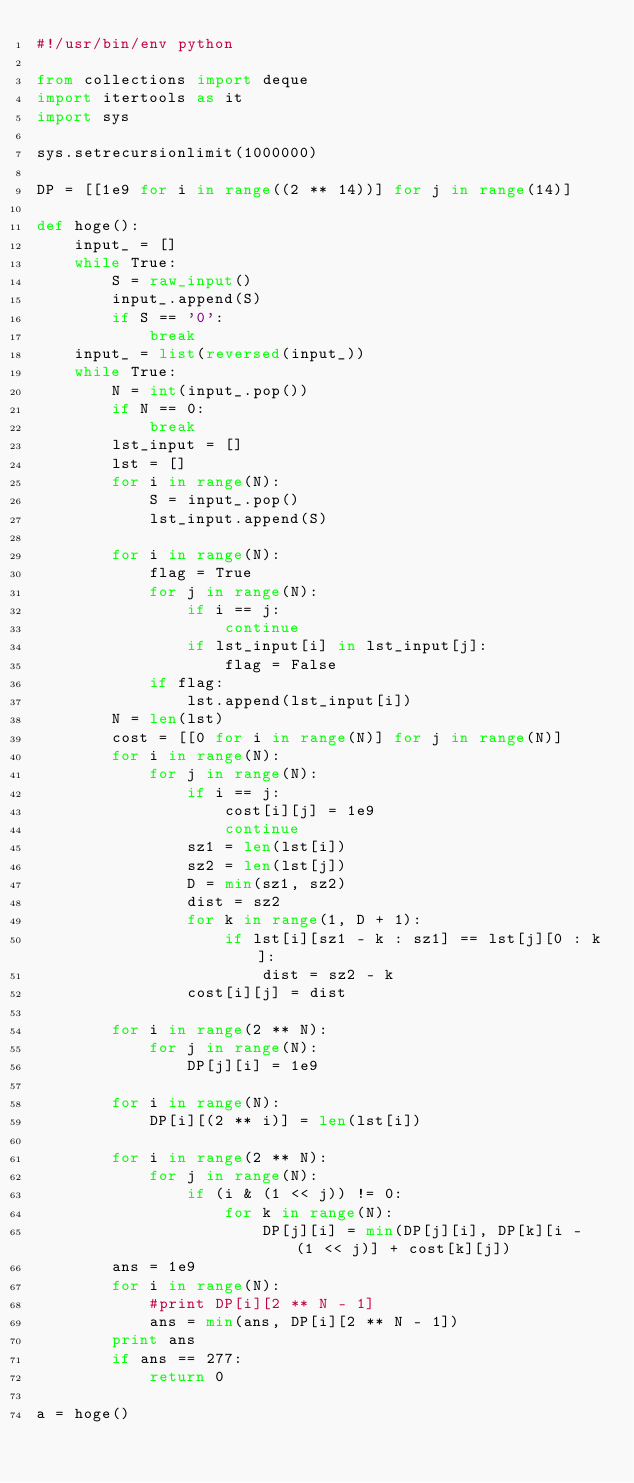<code> <loc_0><loc_0><loc_500><loc_500><_Python_>#!/usr/bin/env python

from collections import deque
import itertools as it
import sys

sys.setrecursionlimit(1000000)

DP = [[1e9 for i in range((2 ** 14))] for j in range(14)]

def hoge():
    input_ = []
    while True:
        S = raw_input()
        input_.append(S)
        if S == '0':
            break
    input_ = list(reversed(input_))
    while True:
        N = int(input_.pop())
        if N == 0:
            break
        lst_input = []
        lst = []
        for i in range(N):
            S = input_.pop()
            lst_input.append(S)
        
        for i in range(N):
            flag = True
            for j in range(N):
                if i == j:
                    continue
                if lst_input[i] in lst_input[j]:
                    flag = False
            if flag:
                lst.append(lst_input[i])
        N = len(lst)
        cost = [[0 for i in range(N)] for j in range(N)]
        for i in range(N):
            for j in range(N):
                if i == j:
                    cost[i][j] = 1e9
                    continue
                sz1 = len(lst[i])
                sz2 = len(lst[j])
                D = min(sz1, sz2)
                dist = sz2
                for k in range(1, D + 1):
                    if lst[i][sz1 - k : sz1] == lst[j][0 : k]:
                        dist = sz2 - k
                cost[i][j] = dist
        
        for i in range(2 ** N):
            for j in range(N):
                DP[j][i] = 1e9
        
        for i in range(N):
            DP[i][(2 ** i)] = len(lst[i])
        
        for i in range(2 ** N):
            for j in range(N):
                if (i & (1 << j)) != 0:
                    for k in range(N):
                        DP[j][i] = min(DP[j][i], DP[k][i - (1 << j)] + cost[k][j])
        ans = 1e9
        for i in range(N):
            #print DP[i][2 ** N - 1]
            ans = min(ans, DP[i][2 ** N - 1])
        print ans
        if ans == 277:
            return 0

a = hoge()
</code> 